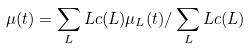Convert formula to latex. <formula><loc_0><loc_0><loc_500><loc_500>\mu ( t ) = \sum _ { L } L c ( L ) \mu _ { L } ( t ) / \sum _ { L } L c ( L )</formula> 